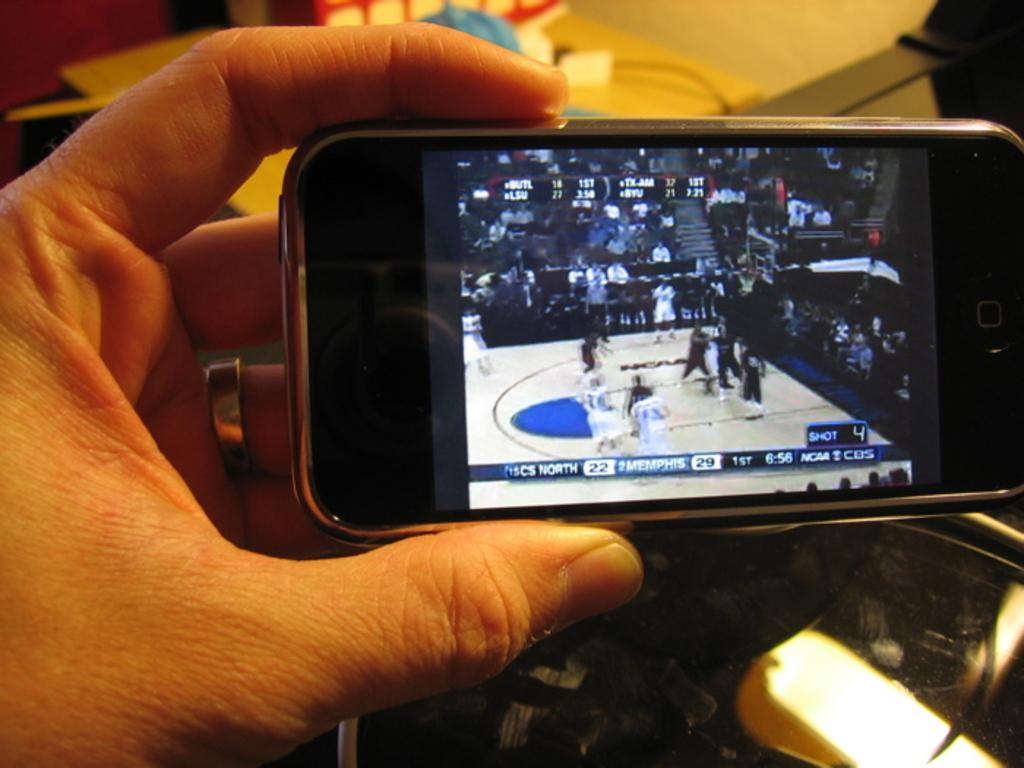<image>
Share a concise interpretation of the image provided. An iphone displaying a sports game and the word Memphis visible 